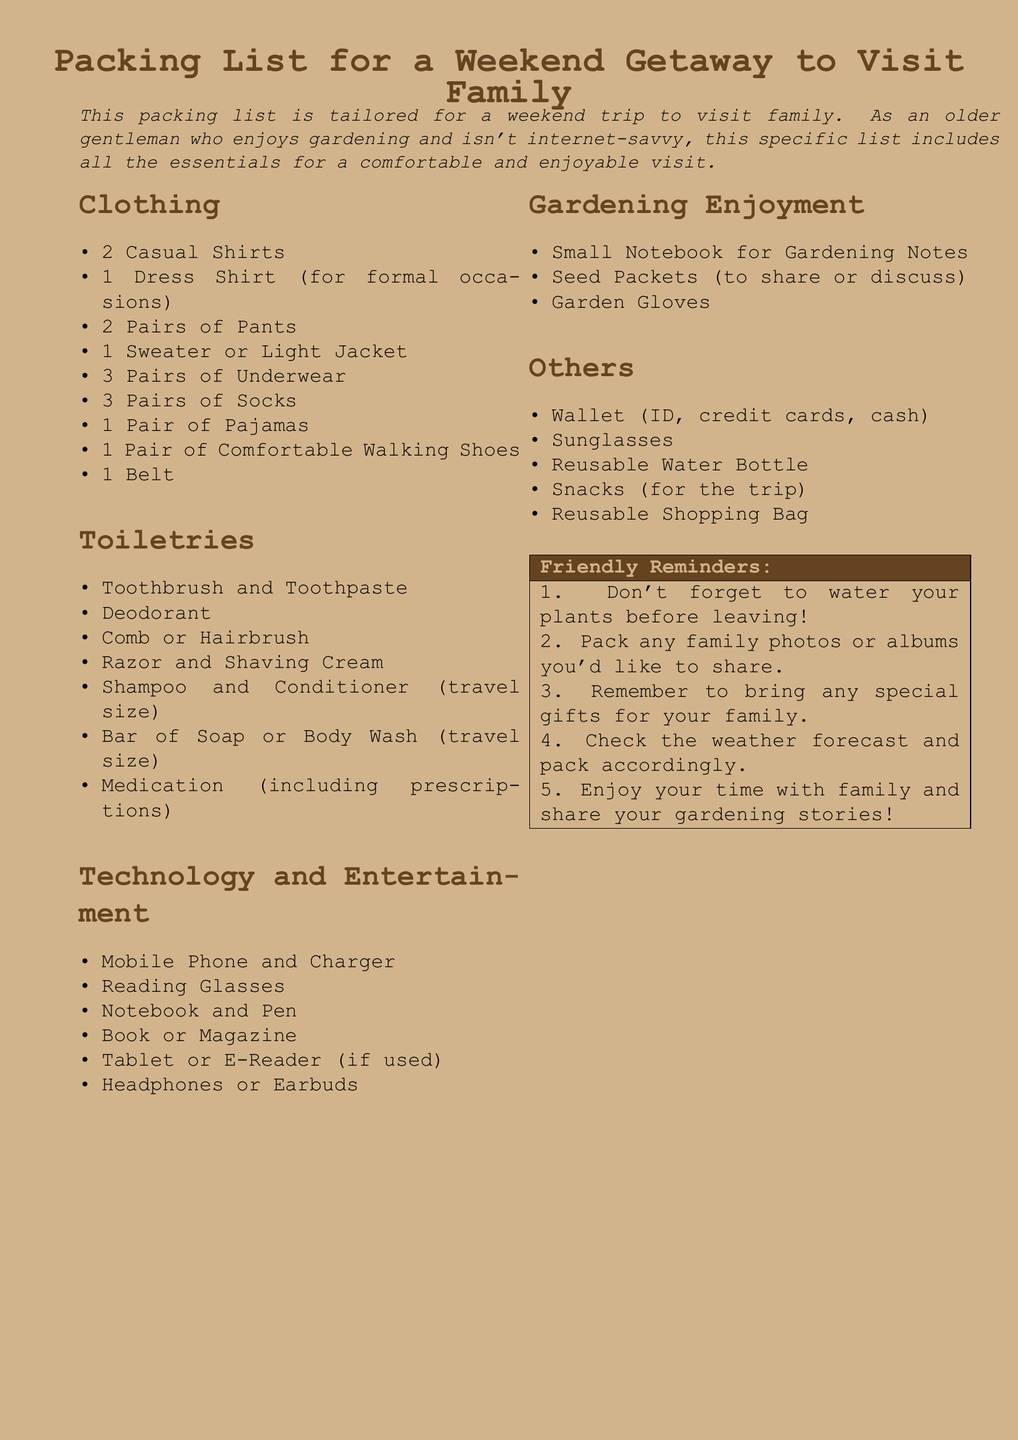What is the total number of pairs of socks? There are 3 pairs of socks listed under the clothing section.
Answer: 3 How many types of toiletries are mentioned? The list includes 7 types of toiletries.
Answer: 7 What should you not forget to do before leaving? The document reminds you to water your plants before leaving.
Answer: Water your plants How many casual shirts are in the clothing list? There are 2 casual shirts mentioned in the clothing section.
Answer: 2 What item is included for gardening enjoyment? The list specifies that garden gloves are included for gardening enjoyment.
Answer: Garden Gloves How many pairs of pants should be packed? The clothing section states to pack 2 pairs of pants.
Answer: 2 What technology item is required for charging? A mobile phone and charger are needed from the technology section.
Answer: Mobile Phone and Charger What should you bring to share your gardening notes? A small notebook for gardening notes is included in the gardening enjoyment section.
Answer: Small Notebook for Gardening Notes What is the purpose of the reusable shopping bag? The reusable shopping bag is included under others, for carrying items during the trip.
Answer: Reusable Shopping Bag 